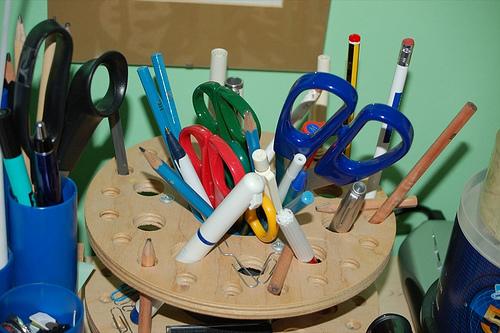Are there any pencils?
Quick response, please. Yes. Is this organized?
Concise answer only. No. What type of utensils are shown?
Answer briefly. Scissors. How many scissors are there?
Short answer required. 5. 